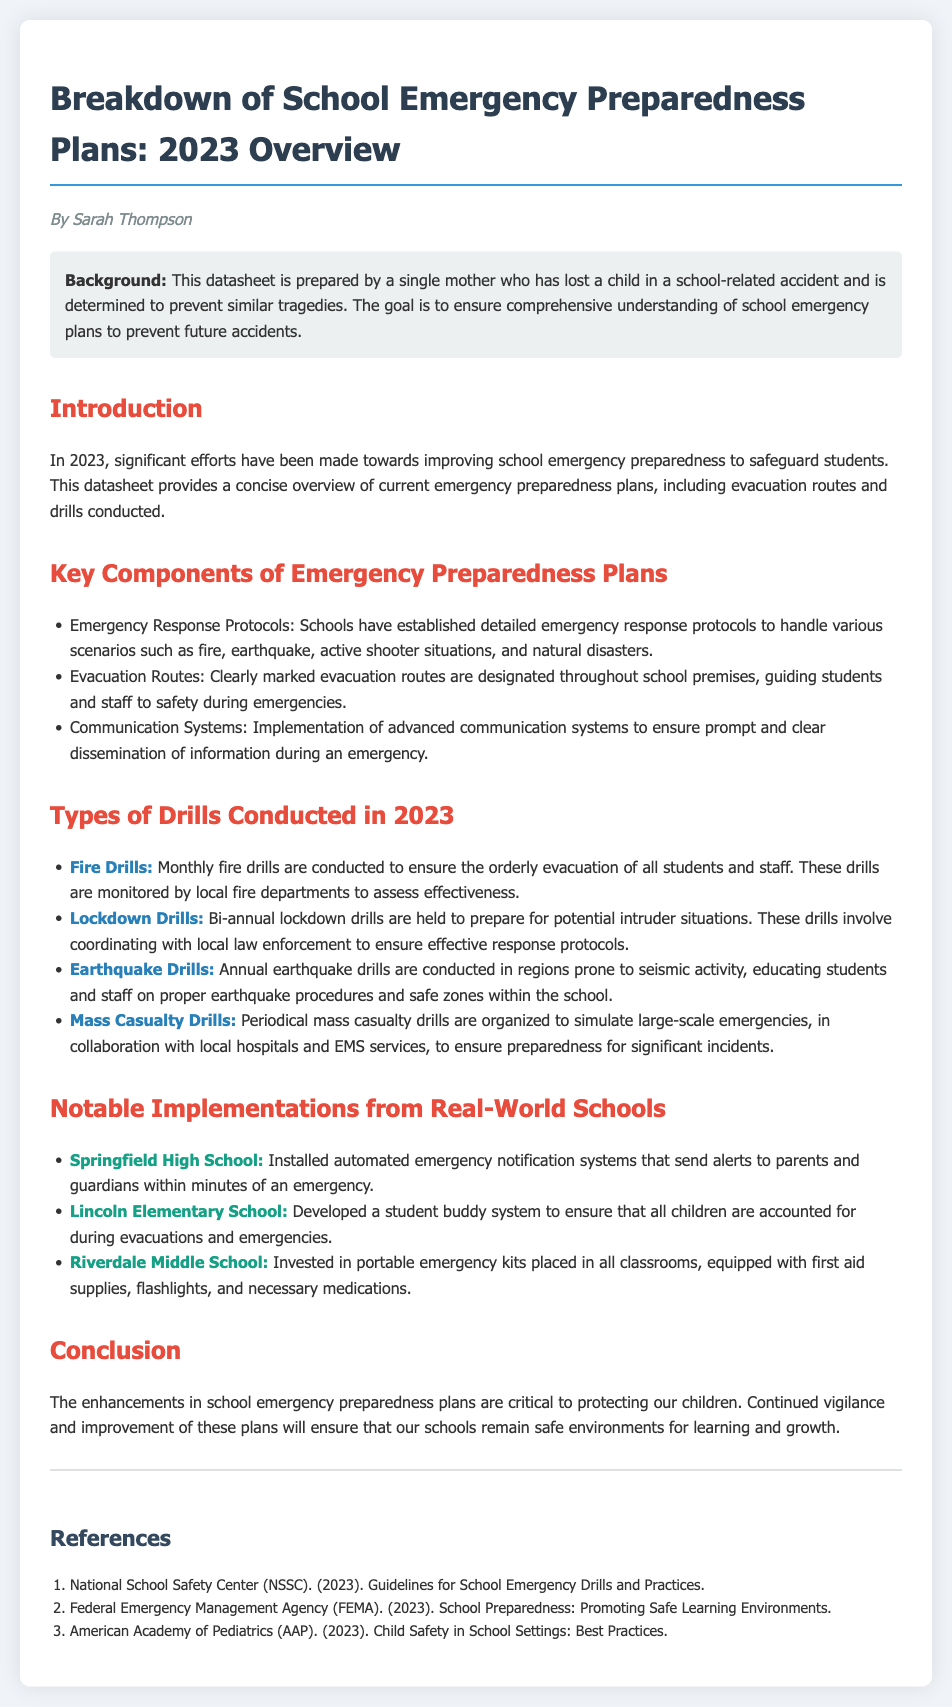what is the author’s name? The document states that it is prepared by Sarah Thompson.
Answer: Sarah Thompson how many types of drills are conducted in 2023? The document lists four types of drills conducted in 2023.
Answer: Four what type of drills are held bi-annually? The document specifies that lockdown drills are conducted bi-annually.
Answer: Lockdown Drills which school installed automatic emergency notification systems? The document mentions Springfield High School as having installed these systems.
Answer: Springfield High School how often are fire drills conducted? The document states that fire drills are conducted monthly.
Answer: Monthly what is an example of a notable implementation from Lincoln Elementary School? The document highlights the development of a student buddy system at Lincoln Elementary School.
Answer: Student buddy system what is the purpose of the periodical mass casualty drills? The document explains that these drills simulate large-scale emergencies for preparedness.
Answer: Simulate large-scale emergencies what background does the author provide? The author shares that they are a single mother who lost a child in a school-related accident.
Answer: Single mother who lost a child what are the guidelines referenced in the document? The document references guidelines from the National School Safety Center for school emergency drills.
Answer: National School Safety Center 